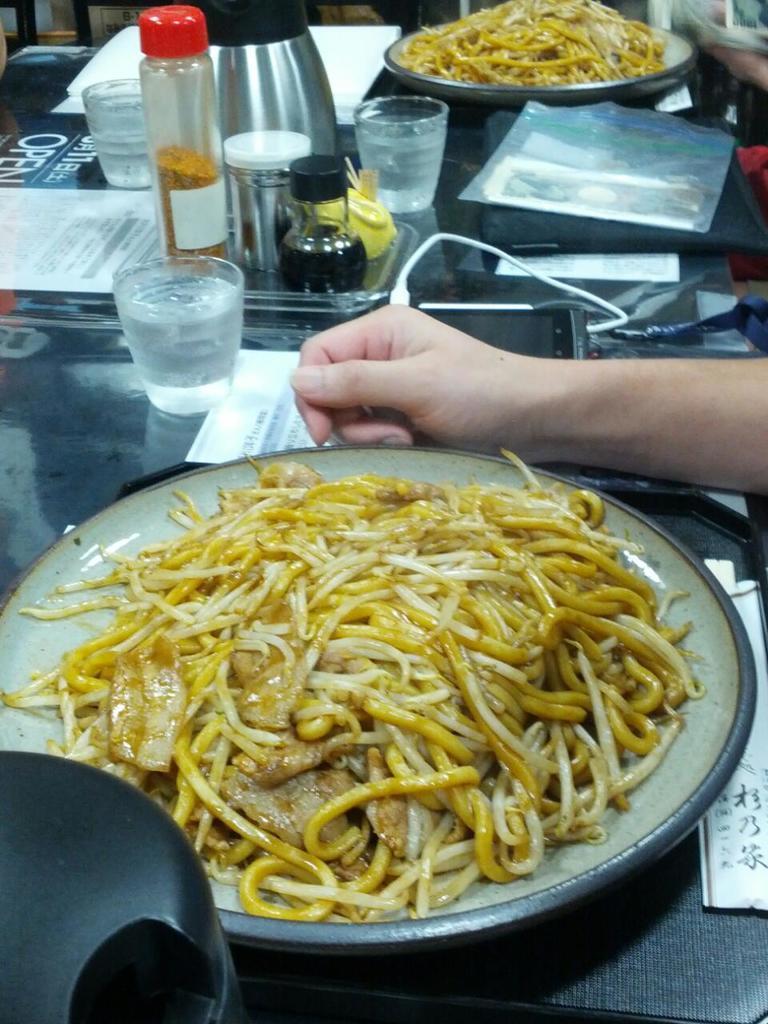Could you give a brief overview of what you see in this image? As we can see in the image there is a table. On table there are noodles, plate, glass and bottle. 